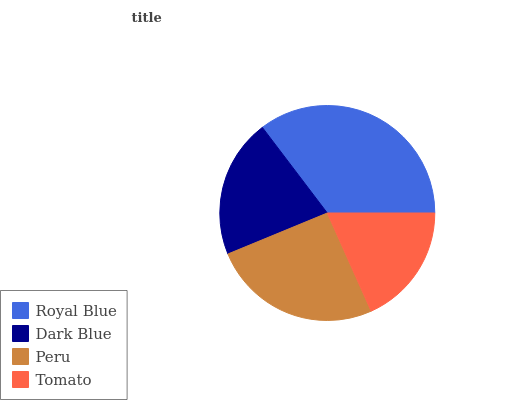Is Tomato the minimum?
Answer yes or no. Yes. Is Royal Blue the maximum?
Answer yes or no. Yes. Is Dark Blue the minimum?
Answer yes or no. No. Is Dark Blue the maximum?
Answer yes or no. No. Is Royal Blue greater than Dark Blue?
Answer yes or no. Yes. Is Dark Blue less than Royal Blue?
Answer yes or no. Yes. Is Dark Blue greater than Royal Blue?
Answer yes or no. No. Is Royal Blue less than Dark Blue?
Answer yes or no. No. Is Peru the high median?
Answer yes or no. Yes. Is Dark Blue the low median?
Answer yes or no. Yes. Is Dark Blue the high median?
Answer yes or no. No. Is Peru the low median?
Answer yes or no. No. 